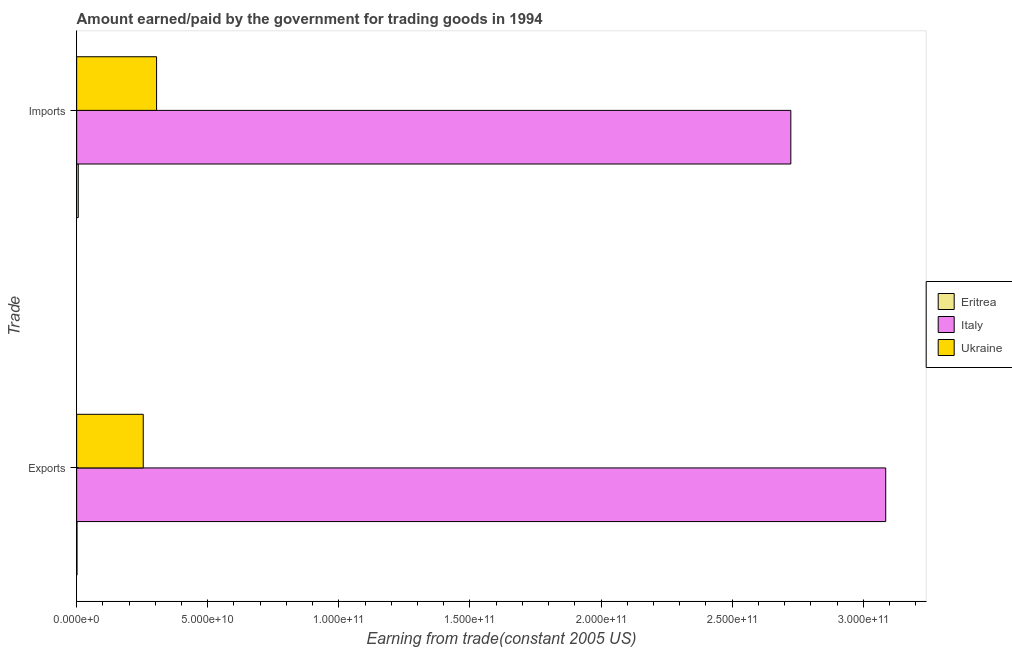Are the number of bars on each tick of the Y-axis equal?
Offer a very short reply. Yes. What is the label of the 1st group of bars from the top?
Offer a very short reply. Imports. What is the amount earned from exports in Eritrea?
Provide a succinct answer. 1.30e+08. Across all countries, what is the maximum amount earned from exports?
Make the answer very short. 3.09e+11. Across all countries, what is the minimum amount paid for imports?
Your answer should be compact. 6.04e+08. In which country was the amount paid for imports minimum?
Provide a succinct answer. Eritrea. What is the total amount paid for imports in the graph?
Ensure brevity in your answer.  3.03e+11. What is the difference between the amount paid for imports in Eritrea and that in Ukraine?
Provide a succinct answer. -2.99e+1. What is the difference between the amount paid for imports in Italy and the amount earned from exports in Eritrea?
Offer a terse response. 2.72e+11. What is the average amount paid for imports per country?
Your answer should be very brief. 1.01e+11. What is the difference between the amount earned from exports and amount paid for imports in Eritrea?
Your answer should be compact. -4.74e+08. In how many countries, is the amount paid for imports greater than 160000000000 US$?
Offer a very short reply. 1. What is the ratio of the amount paid for imports in Eritrea to that in Ukraine?
Give a very brief answer. 0.02. What does the 1st bar from the bottom in Imports represents?
Keep it short and to the point. Eritrea. Are all the bars in the graph horizontal?
Provide a short and direct response. Yes. How many countries are there in the graph?
Offer a terse response. 3. Does the graph contain any zero values?
Your answer should be very brief. No. Where does the legend appear in the graph?
Your answer should be compact. Center right. What is the title of the graph?
Make the answer very short. Amount earned/paid by the government for trading goods in 1994. Does "Portugal" appear as one of the legend labels in the graph?
Your answer should be compact. No. What is the label or title of the X-axis?
Offer a very short reply. Earning from trade(constant 2005 US). What is the label or title of the Y-axis?
Your answer should be compact. Trade. What is the Earning from trade(constant 2005 US) of Eritrea in Exports?
Keep it short and to the point. 1.30e+08. What is the Earning from trade(constant 2005 US) in Italy in Exports?
Keep it short and to the point. 3.09e+11. What is the Earning from trade(constant 2005 US) of Ukraine in Exports?
Make the answer very short. 2.54e+1. What is the Earning from trade(constant 2005 US) in Eritrea in Imports?
Your answer should be compact. 6.04e+08. What is the Earning from trade(constant 2005 US) in Italy in Imports?
Ensure brevity in your answer.  2.72e+11. What is the Earning from trade(constant 2005 US) of Ukraine in Imports?
Make the answer very short. 3.05e+1. Across all Trade, what is the maximum Earning from trade(constant 2005 US) of Eritrea?
Offer a very short reply. 6.04e+08. Across all Trade, what is the maximum Earning from trade(constant 2005 US) in Italy?
Your answer should be very brief. 3.09e+11. Across all Trade, what is the maximum Earning from trade(constant 2005 US) of Ukraine?
Keep it short and to the point. 3.05e+1. Across all Trade, what is the minimum Earning from trade(constant 2005 US) in Eritrea?
Your response must be concise. 1.30e+08. Across all Trade, what is the minimum Earning from trade(constant 2005 US) of Italy?
Offer a very short reply. 2.72e+11. Across all Trade, what is the minimum Earning from trade(constant 2005 US) of Ukraine?
Give a very brief answer. 2.54e+1. What is the total Earning from trade(constant 2005 US) in Eritrea in the graph?
Keep it short and to the point. 7.35e+08. What is the total Earning from trade(constant 2005 US) in Italy in the graph?
Your response must be concise. 5.81e+11. What is the total Earning from trade(constant 2005 US) of Ukraine in the graph?
Your answer should be compact. 5.59e+1. What is the difference between the Earning from trade(constant 2005 US) in Eritrea in Exports and that in Imports?
Keep it short and to the point. -4.74e+08. What is the difference between the Earning from trade(constant 2005 US) of Italy in Exports and that in Imports?
Provide a succinct answer. 3.62e+1. What is the difference between the Earning from trade(constant 2005 US) in Ukraine in Exports and that in Imports?
Offer a terse response. -5.08e+09. What is the difference between the Earning from trade(constant 2005 US) in Eritrea in Exports and the Earning from trade(constant 2005 US) in Italy in Imports?
Ensure brevity in your answer.  -2.72e+11. What is the difference between the Earning from trade(constant 2005 US) in Eritrea in Exports and the Earning from trade(constant 2005 US) in Ukraine in Imports?
Provide a short and direct response. -3.03e+1. What is the difference between the Earning from trade(constant 2005 US) in Italy in Exports and the Earning from trade(constant 2005 US) in Ukraine in Imports?
Give a very brief answer. 2.78e+11. What is the average Earning from trade(constant 2005 US) in Eritrea per Trade?
Your answer should be compact. 3.67e+08. What is the average Earning from trade(constant 2005 US) of Italy per Trade?
Offer a very short reply. 2.90e+11. What is the average Earning from trade(constant 2005 US) of Ukraine per Trade?
Make the answer very short. 2.79e+1. What is the difference between the Earning from trade(constant 2005 US) of Eritrea and Earning from trade(constant 2005 US) of Italy in Exports?
Offer a terse response. -3.08e+11. What is the difference between the Earning from trade(constant 2005 US) of Eritrea and Earning from trade(constant 2005 US) of Ukraine in Exports?
Make the answer very short. -2.53e+1. What is the difference between the Earning from trade(constant 2005 US) of Italy and Earning from trade(constant 2005 US) of Ukraine in Exports?
Give a very brief answer. 2.83e+11. What is the difference between the Earning from trade(constant 2005 US) of Eritrea and Earning from trade(constant 2005 US) of Italy in Imports?
Provide a succinct answer. -2.72e+11. What is the difference between the Earning from trade(constant 2005 US) in Eritrea and Earning from trade(constant 2005 US) in Ukraine in Imports?
Keep it short and to the point. -2.99e+1. What is the difference between the Earning from trade(constant 2005 US) in Italy and Earning from trade(constant 2005 US) in Ukraine in Imports?
Provide a succinct answer. 2.42e+11. What is the ratio of the Earning from trade(constant 2005 US) of Eritrea in Exports to that in Imports?
Your answer should be very brief. 0.22. What is the ratio of the Earning from trade(constant 2005 US) of Italy in Exports to that in Imports?
Keep it short and to the point. 1.13. What is the ratio of the Earning from trade(constant 2005 US) in Ukraine in Exports to that in Imports?
Ensure brevity in your answer.  0.83. What is the difference between the highest and the second highest Earning from trade(constant 2005 US) of Eritrea?
Offer a terse response. 4.74e+08. What is the difference between the highest and the second highest Earning from trade(constant 2005 US) of Italy?
Make the answer very short. 3.62e+1. What is the difference between the highest and the second highest Earning from trade(constant 2005 US) in Ukraine?
Ensure brevity in your answer.  5.08e+09. What is the difference between the highest and the lowest Earning from trade(constant 2005 US) in Eritrea?
Your answer should be very brief. 4.74e+08. What is the difference between the highest and the lowest Earning from trade(constant 2005 US) in Italy?
Provide a short and direct response. 3.62e+1. What is the difference between the highest and the lowest Earning from trade(constant 2005 US) of Ukraine?
Your answer should be very brief. 5.08e+09. 